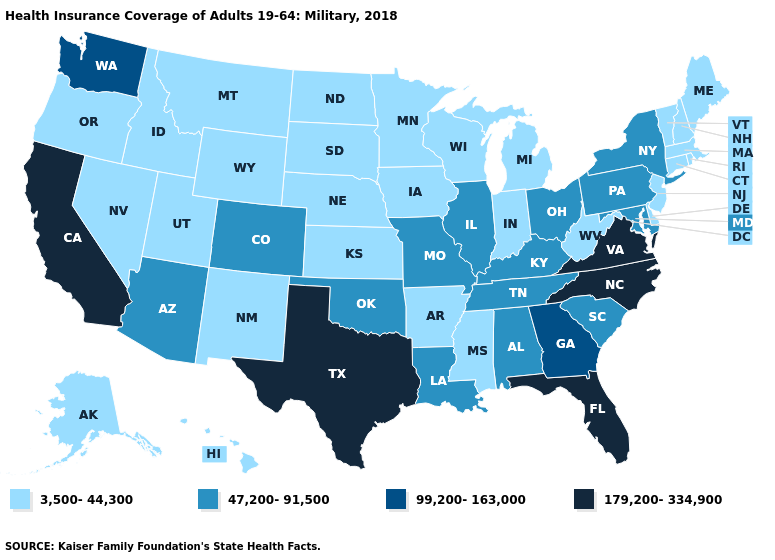What is the value of Missouri?
Be succinct. 47,200-91,500. Is the legend a continuous bar?
Short answer required. No. What is the value of Rhode Island?
Short answer required. 3,500-44,300. Which states have the highest value in the USA?
Write a very short answer. California, Florida, North Carolina, Texas, Virginia. Which states have the highest value in the USA?
Write a very short answer. California, Florida, North Carolina, Texas, Virginia. Name the states that have a value in the range 99,200-163,000?
Concise answer only. Georgia, Washington. What is the lowest value in the USA?
Quick response, please. 3,500-44,300. Does West Virginia have a lower value than Florida?
Keep it brief. Yes. What is the value of California?
Write a very short answer. 179,200-334,900. What is the value of South Dakota?
Answer briefly. 3,500-44,300. Does Virginia have the lowest value in the USA?
Be succinct. No. What is the value of Rhode Island?
Write a very short answer. 3,500-44,300. Does Mississippi have the same value as Louisiana?
Keep it brief. No. Name the states that have a value in the range 99,200-163,000?
Write a very short answer. Georgia, Washington. Does Pennsylvania have a higher value than Kentucky?
Quick response, please. No. 